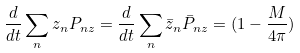Convert formula to latex. <formula><loc_0><loc_0><loc_500><loc_500>\frac { d } { d t } \sum _ { n } z _ { n } P _ { n z } = \frac { d } { d t } \sum _ { n } \bar { z } _ { n } \bar { P } _ { n z } = ( 1 - \frac { M } { 4 \pi } )</formula> 